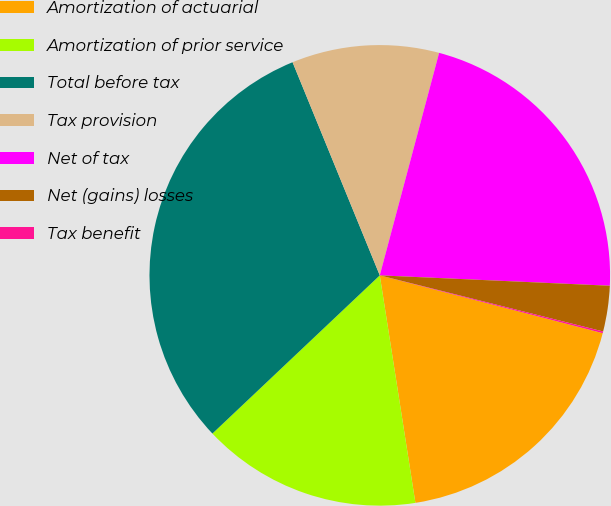Convert chart to OTSL. <chart><loc_0><loc_0><loc_500><loc_500><pie_chart><fcel>Amortization of actuarial<fcel>Amortization of prior service<fcel>Total before tax<fcel>Tax provision<fcel>Net of tax<fcel>Net (gains) losses<fcel>Tax benefit<nl><fcel>18.49%<fcel>15.42%<fcel>30.87%<fcel>10.33%<fcel>21.57%<fcel>3.2%<fcel>0.12%<nl></chart> 